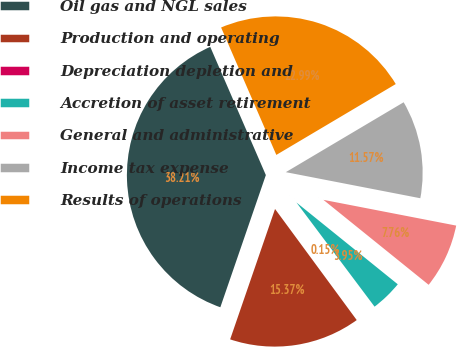<chart> <loc_0><loc_0><loc_500><loc_500><pie_chart><fcel>Oil gas and NGL sales<fcel>Production and operating<fcel>Depreciation depletion and<fcel>Accretion of asset retirement<fcel>General and administrative<fcel>Income tax expense<fcel>Results of operations<nl><fcel>38.21%<fcel>15.37%<fcel>0.15%<fcel>3.95%<fcel>7.76%<fcel>11.57%<fcel>22.99%<nl></chart> 